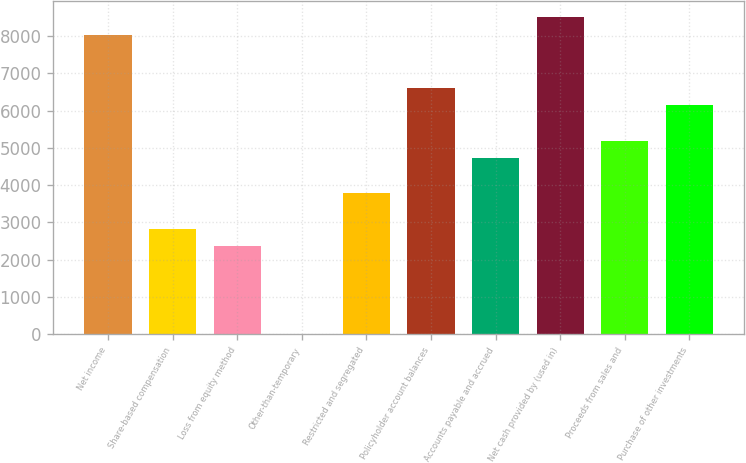<chart> <loc_0><loc_0><loc_500><loc_500><bar_chart><fcel>Net income<fcel>Share-based compensation<fcel>Loss from equity method<fcel>Other-than-temporary<fcel>Restricted and segregated<fcel>Policyholder account balances<fcel>Accounts payable and accrued<fcel>Net cash provided by (used in)<fcel>Proceeds from sales and<fcel>Purchase of other investments<nl><fcel>8029<fcel>2837<fcel>2365<fcel>5<fcel>3781<fcel>6613<fcel>4725<fcel>8501<fcel>5197<fcel>6141<nl></chart> 